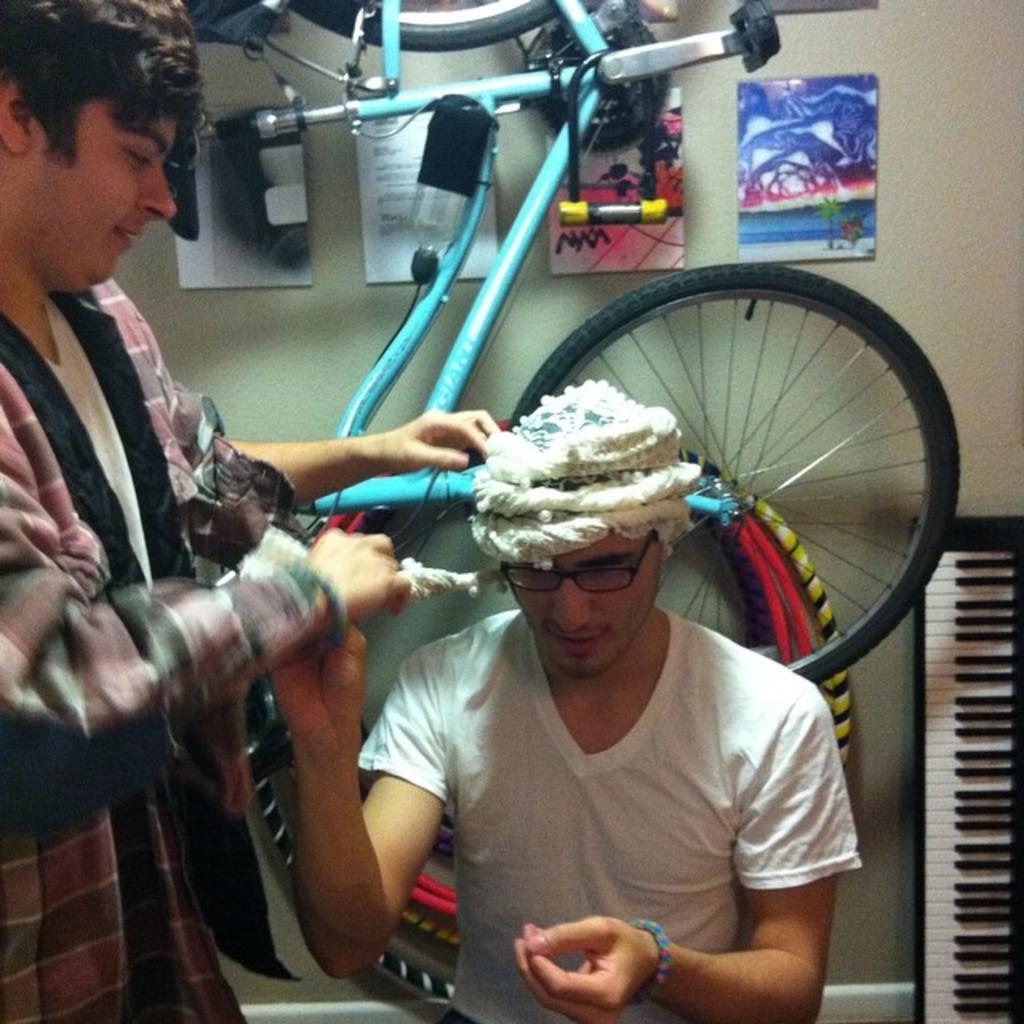How would you summarize this image in a sentence or two? In the picture I can see a person wearing white color T-shirt, spectacles and head wear on his head is sitting, here I can see a person on the left side of the image. In the background, I can see a cycle, piano and posters on the wall. 